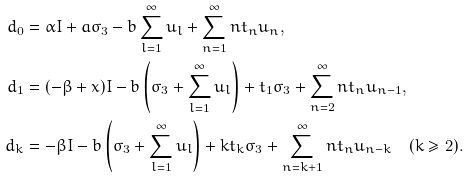Convert formula to latex. <formula><loc_0><loc_0><loc_500><loc_500>d _ { 0 } & = \alpha I + a \sigma _ { 3 } - b \sum _ { l = 1 } ^ { \infty } u _ { l } + \sum _ { n = 1 } ^ { \infty } n t _ { n } u _ { n } , \\ d _ { 1 } & = ( - \beta + x ) I - b \left ( \sigma _ { 3 } + \sum _ { l = 1 } ^ { \infty } u _ { l } \right ) + t _ { 1 } \sigma _ { 3 } + \sum _ { n = 2 } ^ { \infty } n t _ { n } u _ { n - 1 } , \\ d _ { k } & = - \beta I - b \left ( \sigma _ { 3 } + \sum _ { l = 1 } ^ { \infty } u _ { l } \right ) + k t _ { k } \sigma _ { 3 } + \sum _ { n = k + 1 } ^ { \infty } n t _ { n } u _ { n - k } \quad ( k \geq 2 ) .</formula> 